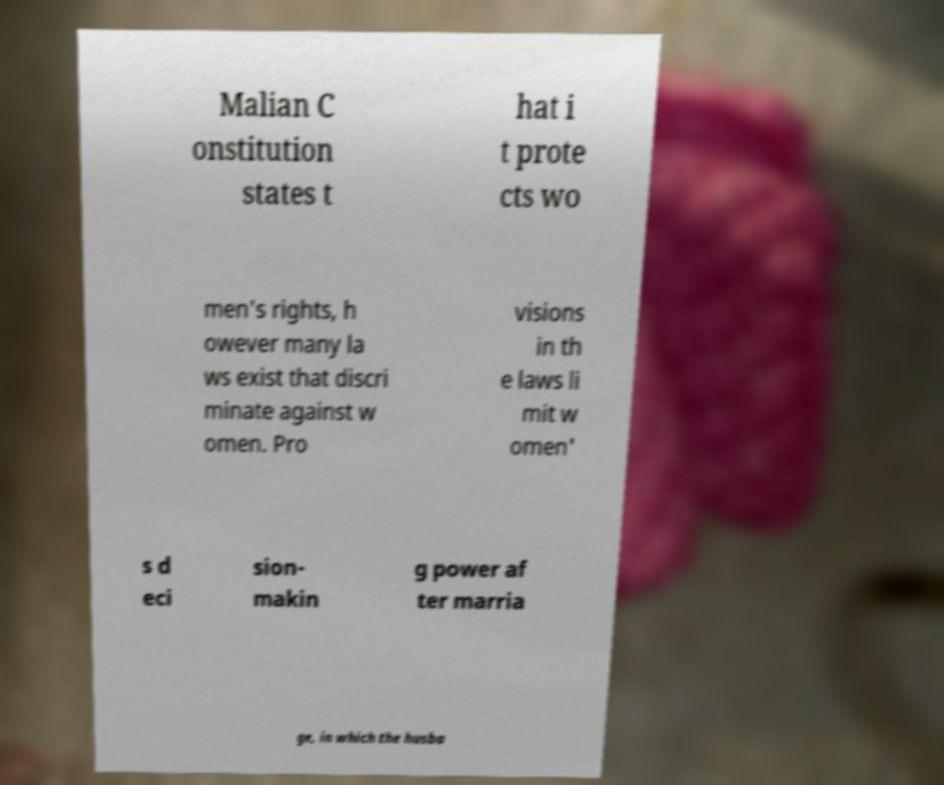Could you extract and type out the text from this image? Malian C onstitution states t hat i t prote cts wo men's rights, h owever many la ws exist that discri minate against w omen. Pro visions in th e laws li mit w omen' s d eci sion- makin g power af ter marria ge, in which the husba 